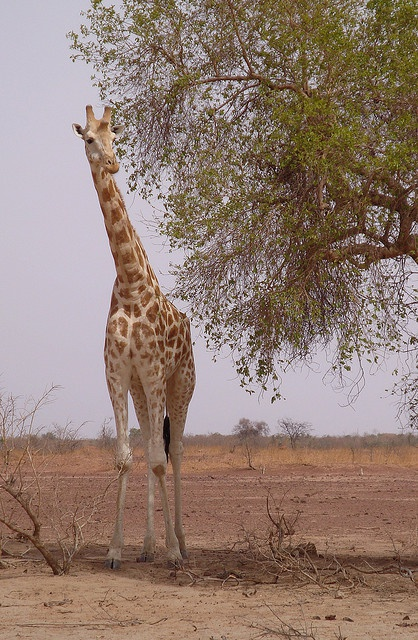Describe the objects in this image and their specific colors. I can see a giraffe in lightgray, gray, brown, and maroon tones in this image. 